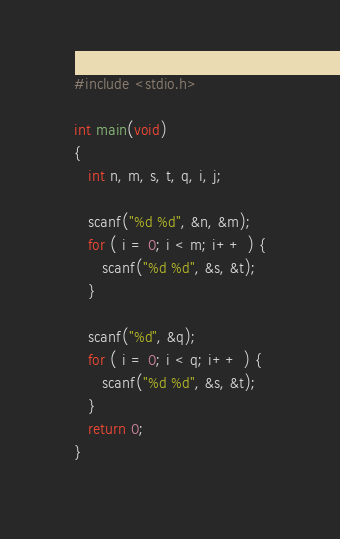Convert code to text. <code><loc_0><loc_0><loc_500><loc_500><_C_>#include <stdio.h>

int main(void)
{
   int n, m, s, t, q, i, j;

   scanf("%d %d", &n, &m);
   for ( i = 0; i < m; i++ ) {
      scanf("%d %d", &s, &t);
   }

   scanf("%d", &q);
   for ( i = 0; i < q; i++ ) {
      scanf("%d %d", &s, &t);
   }
   return 0;
}</code> 